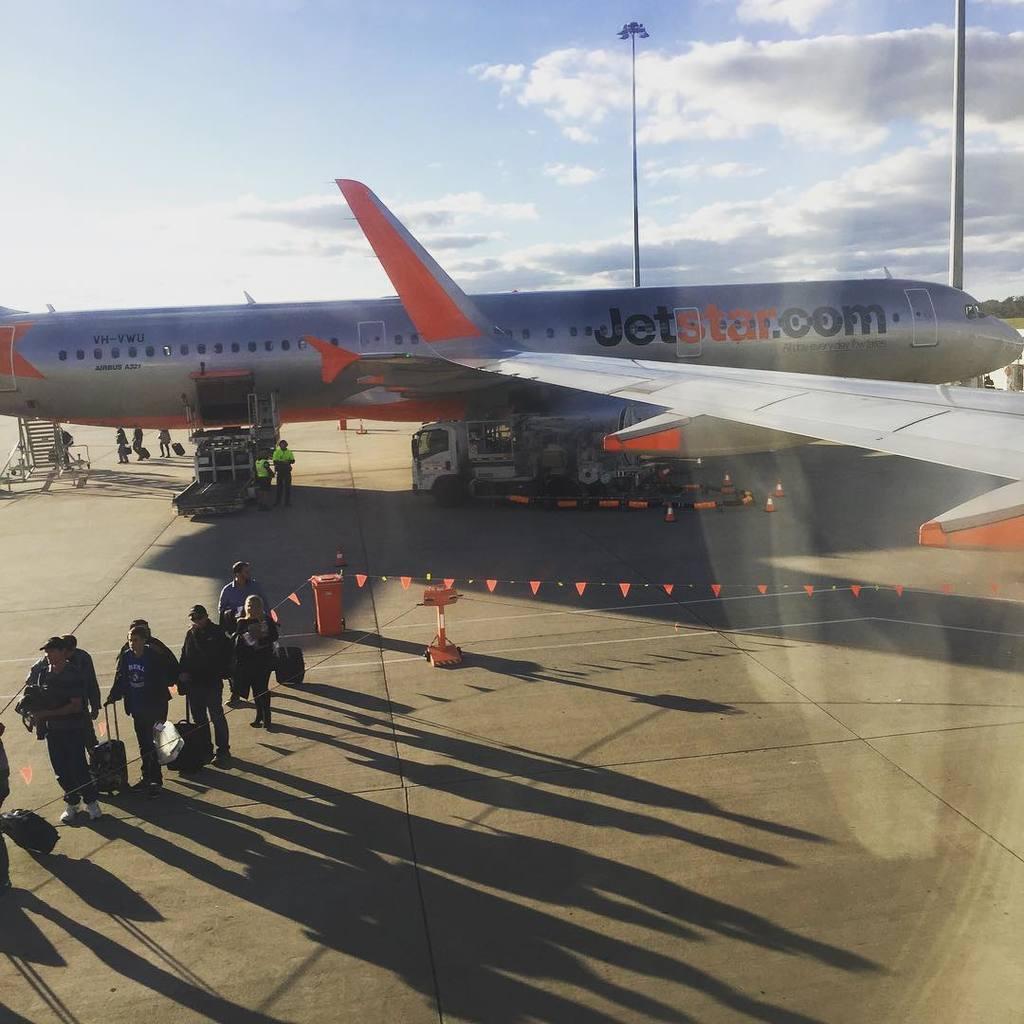What website is on the plane?
Provide a short and direct response. Jetstar.com. 